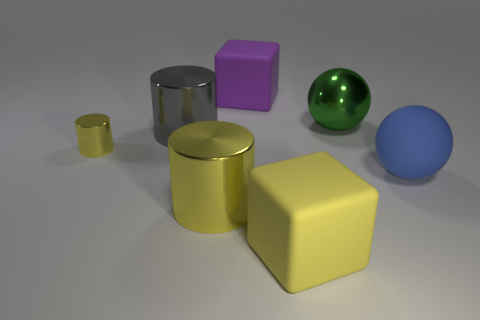Add 2 big green metal balls. How many objects exist? 9 Subtract all red cylinders. Subtract all gray blocks. How many cylinders are left? 3 Subtract all cylinders. How many objects are left? 4 Subtract 0 blue cubes. How many objects are left? 7 Subtract all large red balls. Subtract all small metal objects. How many objects are left? 6 Add 5 purple matte things. How many purple matte things are left? 6 Add 7 purple rubber things. How many purple rubber things exist? 8 